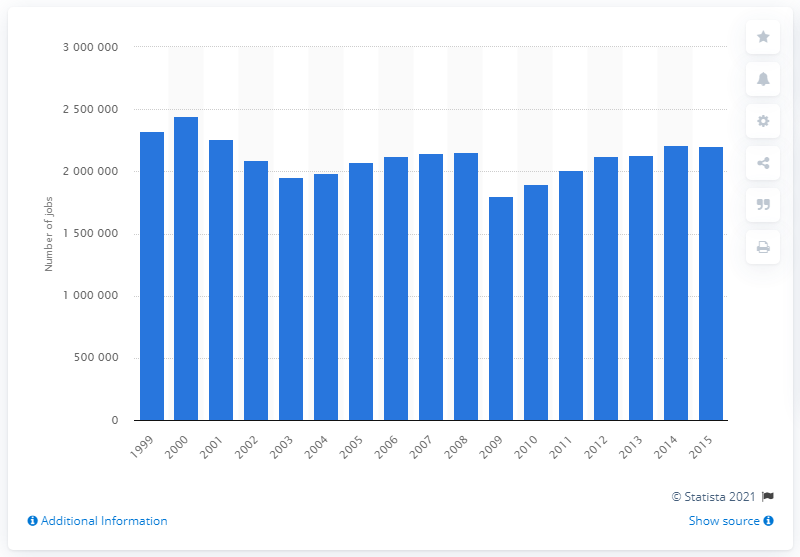Highlight a few significant elements in this photo. In 2015, exports of goods to NAFTA countries supported a total of 2,205,703 jobs in the United States. 